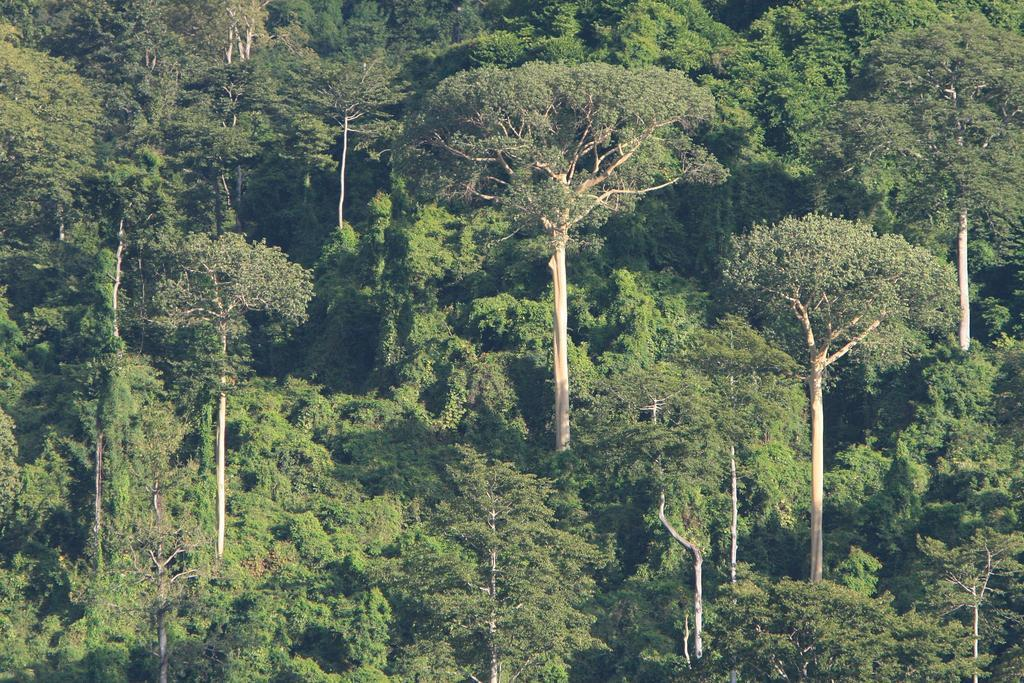What type of vegetation can be seen in the image? There are trees in the image. What is the point of the sidewalk in the image? There is no sidewalk present in the image; it only features trees. 